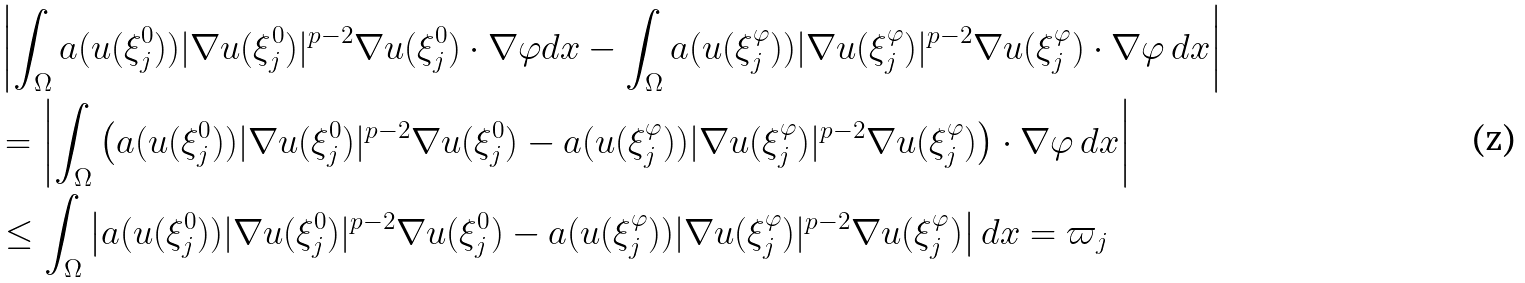<formula> <loc_0><loc_0><loc_500><loc_500>& \left | \int _ { \Omega } a ( u ( \xi _ { j } ^ { 0 } ) ) | \nabla u ( \xi _ { j } ^ { 0 } ) | ^ { p - 2 } \nabla u ( \xi _ { j } ^ { 0 } ) \cdot \nabla \varphi d x - \int _ { \Omega } a ( u ( \xi _ { j } ^ { \varphi } ) ) | \nabla u ( \xi _ { j } ^ { \varphi } ) | ^ { p - 2 } \nabla u ( \xi _ { j } ^ { \varphi } ) \cdot \nabla \varphi \, d x \right | \\ & = \left | \int _ { \Omega } \left ( a ( u ( \xi _ { j } ^ { 0 } ) ) | \nabla u ( \xi _ { j } ^ { 0 } ) | ^ { p - 2 } \nabla u ( \xi _ { j } ^ { 0 } ) - a ( u ( \xi _ { j } ^ { \varphi } ) ) | \nabla u ( \xi _ { j } ^ { \varphi } ) | ^ { p - 2 } \nabla u ( \xi _ { j } ^ { \varphi } ) \right ) \cdot \nabla \varphi \, d x \right | \\ & \leq \int _ { \Omega } \left | a ( u ( \xi _ { j } ^ { 0 } ) ) | \nabla u ( \xi _ { j } ^ { 0 } ) | ^ { p - 2 } \nabla u ( \xi _ { j } ^ { 0 } ) - a ( u ( \xi _ { j } ^ { \varphi } ) ) | \nabla u ( \xi _ { j } ^ { \varphi } ) | ^ { p - 2 } \nabla u ( \xi _ { j } ^ { \varphi } ) \right | d x = \varpi _ { j }</formula> 